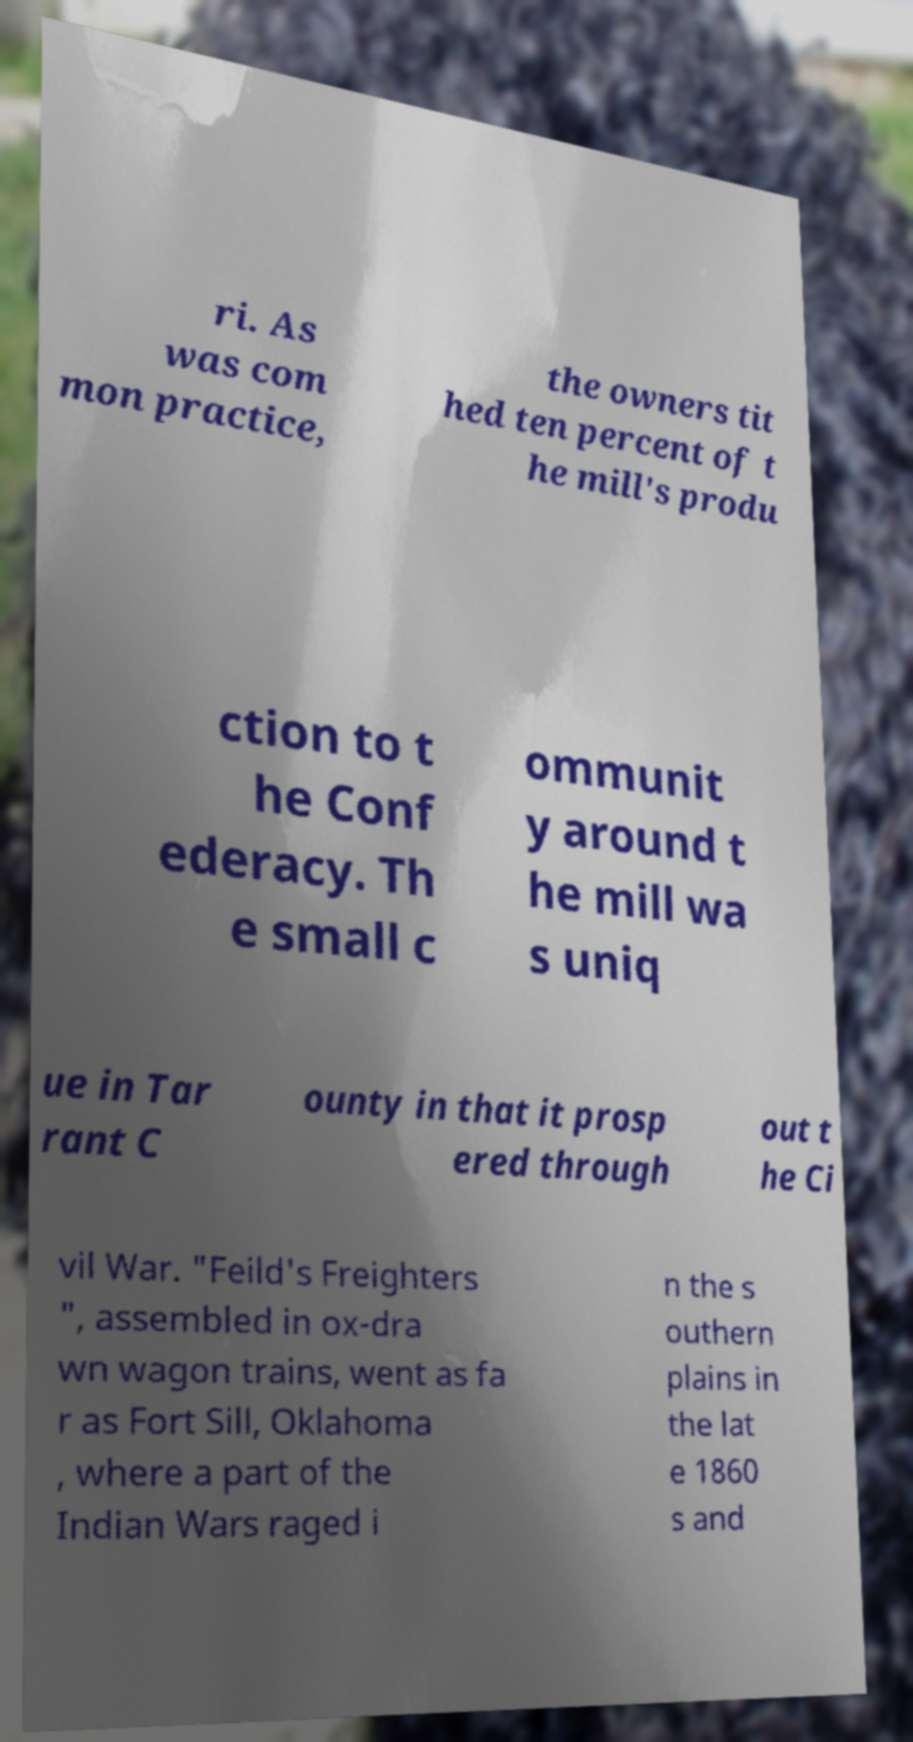For documentation purposes, I need the text within this image transcribed. Could you provide that? ri. As was com mon practice, the owners tit hed ten percent of t he mill's produ ction to t he Conf ederacy. Th e small c ommunit y around t he mill wa s uniq ue in Tar rant C ounty in that it prosp ered through out t he Ci vil War. "Feild's Freighters ", assembled in ox-dra wn wagon trains, went as fa r as Fort Sill, Oklahoma , where a part of the Indian Wars raged i n the s outhern plains in the lat e 1860 s and 